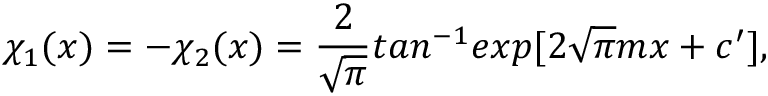Convert formula to latex. <formula><loc_0><loc_0><loc_500><loc_500>\chi _ { 1 } ( x ) = - \chi _ { 2 } ( x ) = \frac { 2 } { \sqrt { \pi } } t a n ^ { - 1 } e x p [ 2 \sqrt { \pi } m x + c ^ { \prime } ] ,</formula> 